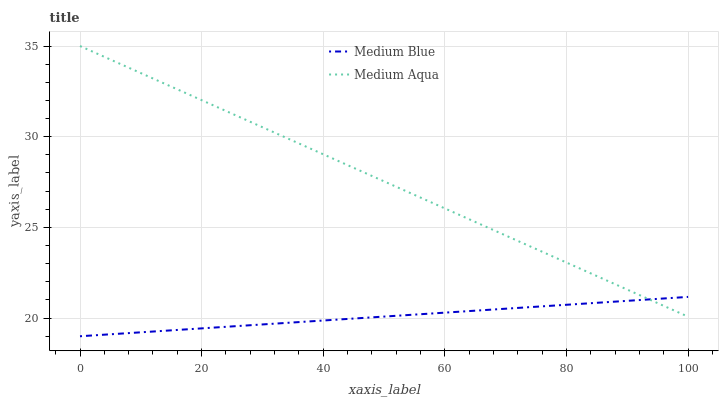Does Medium Blue have the minimum area under the curve?
Answer yes or no. Yes. Does Medium Aqua have the maximum area under the curve?
Answer yes or no. Yes. Does Medium Blue have the maximum area under the curve?
Answer yes or no. No. Is Medium Blue the smoothest?
Answer yes or no. Yes. Is Medium Aqua the roughest?
Answer yes or no. Yes. Is Medium Blue the roughest?
Answer yes or no. No. Does Medium Blue have the lowest value?
Answer yes or no. Yes. Does Medium Aqua have the highest value?
Answer yes or no. Yes. Does Medium Blue have the highest value?
Answer yes or no. No. Does Medium Aqua intersect Medium Blue?
Answer yes or no. Yes. Is Medium Aqua less than Medium Blue?
Answer yes or no. No. Is Medium Aqua greater than Medium Blue?
Answer yes or no. No. 